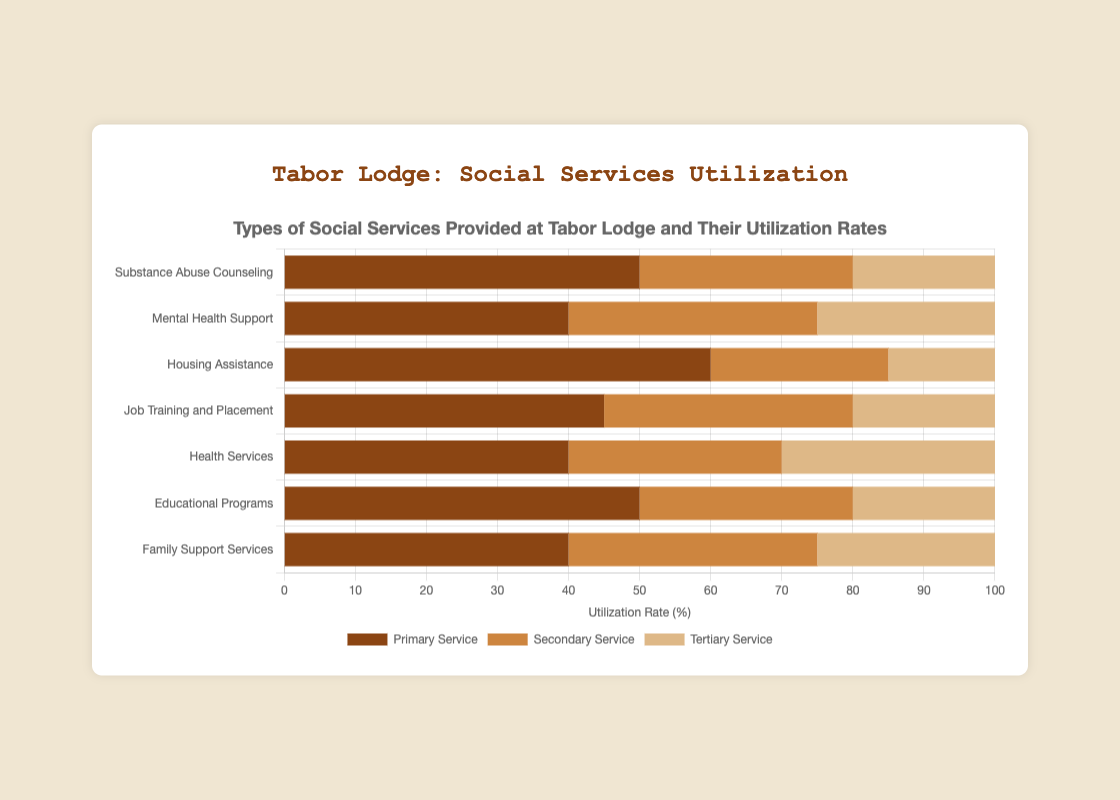Which social service has the highest utilization rate for the primary service? The bar representing Housing Assistance for the primary service is the longest, reaching 60%. This indicates it has the highest utilization for the primary service.
Answer: Housing Assistance How do the secondary service utilization rates compare between Health Services and Family Support Services? Health Services and Family Support Services have secondary service utilization rates of 30% and 35% respectively. By comparing the bar lengths, Family Support Services has a higher secondary service utilization rate.
Answer: Family Support Services What is the overall utilization rate for Substance Abuse Counseling? For Substance Abuse Counseling, sum the primary (50%), secondary (30%), and tertiary (20%) services. The overall utilization rate is 50 + 30 + 20 = 100%.
Answer: 100% Which service has the lowest tertiary service utilization rate, and what is it? By comparing the tertiary service bars for each social service, Housing Assistance has the shortest tertiary service bar, equating to 15%.
Answer: Housing Assistance, 15% What is the difference in primary service utilization rates between Job Training and Placement and Educational Programs? The primary service utilization rate for Job Training and Placement is 45%, and for Educational Programs, it is 50%. The difference is 50% - 45% = 5%.
Answer: 5% Which two services have equal tertiary service utilization rates? Comparing the tertiary service bars, Health Services and Educational Programs both have tertiary rates of 30%.
Answer: Health Services and Educational Programs Are there any services where the primary and secondary utilization rates are the same? For Housing Assistance, the primary rate is 60%, and the secondary rate is 25%. No service has the same primary and secondary rates based on the figure.
Answer: None What is the average utilization rate for secondary services across all social services? Add the secondary rates: 30 + 35 + 25 + 35 + 30 + 30 + 35 = 220. There are 7 services, so the average is 220 / 7 ≈ 31.43%.
Answer: 31.43% Which social service has the smallest overall utilization rate, and what is it? Adding the rates for each service, the smallest total is for Housing Assistance with 60 + 25 + 15 = 100%. However, other services like Substance Abuse Counseling tie. To confirm, the sum for each should be checked.
Answer: Substance Abuse Counseling and Housing Assistance, 100% How does the utilization of Family Support Services' primary service compare to that of Mental Health Support? The utilization rate of Family Support Services' primary service is 40%, which is the same as that of Mental Health Support. Both are equal.
Answer: Equal 